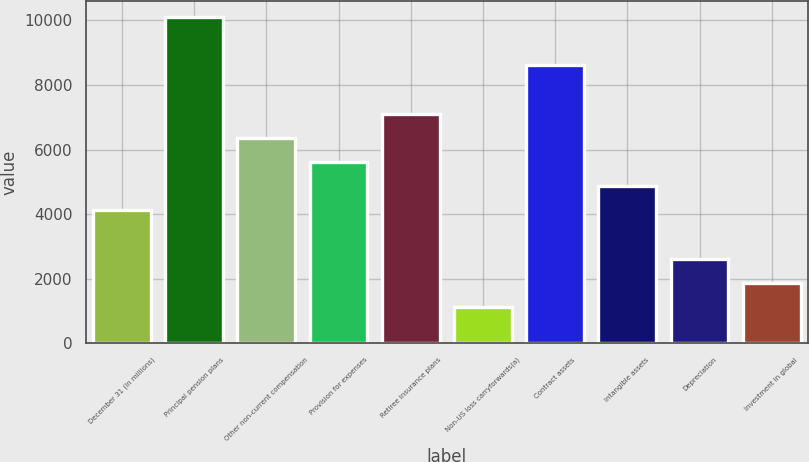Convert chart to OTSL. <chart><loc_0><loc_0><loc_500><loc_500><bar_chart><fcel>December 31 (In millions)<fcel>Principal pension plans<fcel>Other non-current compensation<fcel>Provision for expenses<fcel>Retiree insurance plans<fcel>Non-US loss carryforwards(a)<fcel>Contract assets<fcel>Intangible assets<fcel>Depreciation<fcel>Investment in global<nl><fcel>4115<fcel>10105.4<fcel>6361.4<fcel>5612.6<fcel>7110.2<fcel>1119.8<fcel>8607.8<fcel>4863.8<fcel>2617.4<fcel>1868.6<nl></chart> 